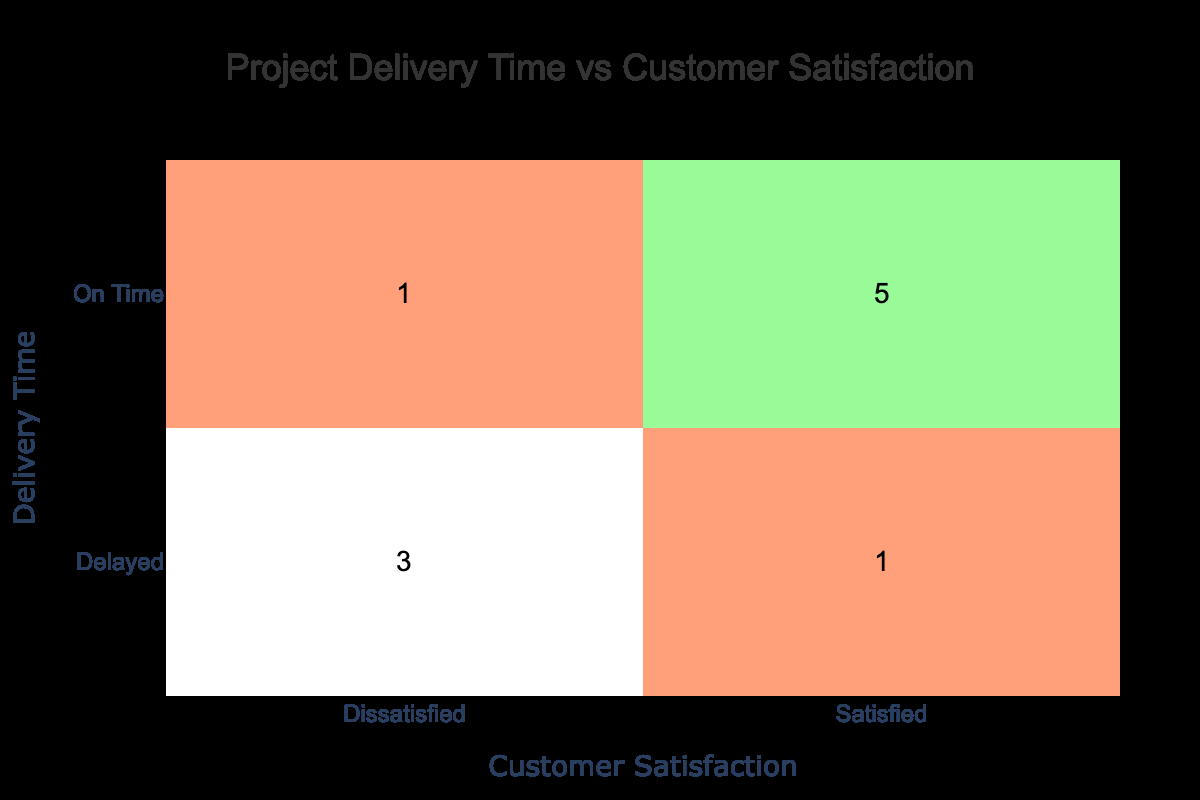What is the total number of projects delivered on time? By reviewing the table, we can see the projects classified under the "On Time" category. The projects are: Website Redesign, Cloud Migration, Data Analysis, Social Media Strategy, and SEO Optimization. This gives us a total of 5 projects delivered on time.
Answer: 5 How many projects had dissatisfied customers? Looking at the table, we can identify the projects with the "Dissatisfied" customer satisfaction rating, which are Mobile App Development, ERP Implementation, E-commerce Platform Build, and IT Infrastructure Upgrade. This totals 4 projects.
Answer: 4 What percentage of projects delivered on time received a satisfied rating? To find this, we first see that there are 5 projects delivered on time, and out of these, 4 projects received a "Satisfied" rating (Website Redesign, Cloud Migration, Data Analysis, Social Media Strategy, and SEO Optimization). The percentage can be calculated as (4 satisfied/5 total) * 100 = 80%.
Answer: 80 percent Is there any project that was delivered on time and had a dissatisfied rating? Referring to the table, we observe the "On Time" category and see that the only project that falls under this category with a "Dissatisfied" rating is the ERP Implementation. This means there is one such project.
Answer: Yes Which delivery time category had the highest number of satisfied customers? When analyzing the data, the "On Time" delivery time category has 4 satisfied customers compared to the "Delayed" category, which has only 1 satisfied customer (Marketing Campaign). This indicates that "On Time" has the highest number.
Answer: On Time What is the total number of projects that were delayed? In examining the table, the projects that fall under the "Delayed" category are Mobile App Development, Marketing Campaign, E-commerce Platform Build, and IT Infrastructure Upgrade. Hence, we can conclude that there are 4 delayed projects.
Answer: 4 Are all projects that were delivered late rated as dissatisfied? Observing the "Delayed" category, the ratings for the projects are as follows: Mobile App Development (Dissatisfied), Marketing Campaign (Satisfied), E-commerce Platform Build (Dissatisfied), and IT Infrastructure Upgrade (Dissatisfied). Since not all ratings are dissatisfied (Marketing Campaign is satisfied), the answer is no.
Answer: No What is the ratio of satisfied customers for projects delivered on time to those delivered late? From the data, the "On Time" projects have 4 satisfied ratings and the "Delayed" projects have 1 satisfied rating. The ratio is therefore calculated as 4 satisfied (on time) to 1 satisfied (delayed), which simplifies to 4:1.
Answer: 4:1 